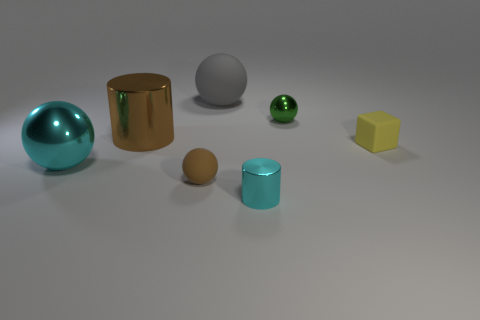Subtract all brown balls. How many balls are left? 3 Subtract all brown spheres. How many spheres are left? 3 Subtract 1 balls. How many balls are left? 3 Subtract all blocks. How many objects are left? 6 Subtract all brown balls. Subtract all green cylinders. How many balls are left? 3 Add 3 small yellow blocks. How many objects exist? 10 Subtract 0 gray cubes. How many objects are left? 7 Subtract all large brown cylinders. Subtract all cubes. How many objects are left? 5 Add 3 gray balls. How many gray balls are left? 4 Add 2 green matte spheres. How many green matte spheres exist? 2 